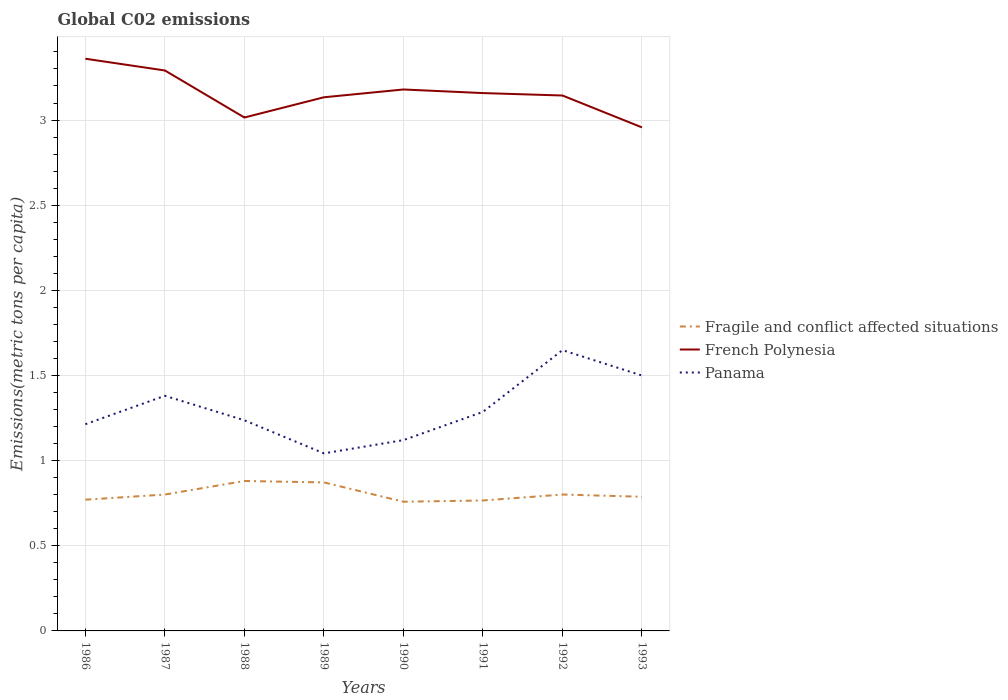How many different coloured lines are there?
Your response must be concise. 3. Across all years, what is the maximum amount of CO2 emitted in in Panama?
Give a very brief answer. 1.04. What is the total amount of CO2 emitted in in Fragile and conflict affected situations in the graph?
Give a very brief answer. 0.01. What is the difference between the highest and the second highest amount of CO2 emitted in in Panama?
Make the answer very short. 0.61. What is the difference between the highest and the lowest amount of CO2 emitted in in French Polynesia?
Ensure brevity in your answer.  4. How many years are there in the graph?
Offer a terse response. 8. Are the values on the major ticks of Y-axis written in scientific E-notation?
Your answer should be compact. No. Does the graph contain any zero values?
Give a very brief answer. No. How many legend labels are there?
Your answer should be very brief. 3. What is the title of the graph?
Provide a succinct answer. Global C02 emissions. Does "Uzbekistan" appear as one of the legend labels in the graph?
Provide a succinct answer. No. What is the label or title of the Y-axis?
Provide a succinct answer. Emissions(metric tons per capita). What is the Emissions(metric tons per capita) of Fragile and conflict affected situations in 1986?
Keep it short and to the point. 0.77. What is the Emissions(metric tons per capita) in French Polynesia in 1986?
Provide a short and direct response. 3.36. What is the Emissions(metric tons per capita) of Panama in 1986?
Offer a terse response. 1.21. What is the Emissions(metric tons per capita) of Fragile and conflict affected situations in 1987?
Make the answer very short. 0.8. What is the Emissions(metric tons per capita) of French Polynesia in 1987?
Provide a succinct answer. 3.29. What is the Emissions(metric tons per capita) of Panama in 1987?
Offer a terse response. 1.38. What is the Emissions(metric tons per capita) in Fragile and conflict affected situations in 1988?
Keep it short and to the point. 0.88. What is the Emissions(metric tons per capita) of French Polynesia in 1988?
Give a very brief answer. 3.01. What is the Emissions(metric tons per capita) of Panama in 1988?
Provide a short and direct response. 1.24. What is the Emissions(metric tons per capita) in Fragile and conflict affected situations in 1989?
Your answer should be compact. 0.87. What is the Emissions(metric tons per capita) in French Polynesia in 1989?
Ensure brevity in your answer.  3.13. What is the Emissions(metric tons per capita) in Panama in 1989?
Give a very brief answer. 1.04. What is the Emissions(metric tons per capita) of Fragile and conflict affected situations in 1990?
Provide a short and direct response. 0.76. What is the Emissions(metric tons per capita) in French Polynesia in 1990?
Provide a short and direct response. 3.18. What is the Emissions(metric tons per capita) in Panama in 1990?
Your answer should be very brief. 1.12. What is the Emissions(metric tons per capita) in Fragile and conflict affected situations in 1991?
Give a very brief answer. 0.77. What is the Emissions(metric tons per capita) in French Polynesia in 1991?
Offer a terse response. 3.16. What is the Emissions(metric tons per capita) in Panama in 1991?
Offer a very short reply. 1.29. What is the Emissions(metric tons per capita) of Fragile and conflict affected situations in 1992?
Your answer should be compact. 0.8. What is the Emissions(metric tons per capita) in French Polynesia in 1992?
Keep it short and to the point. 3.14. What is the Emissions(metric tons per capita) in Panama in 1992?
Provide a short and direct response. 1.65. What is the Emissions(metric tons per capita) of Fragile and conflict affected situations in 1993?
Offer a terse response. 0.79. What is the Emissions(metric tons per capita) in French Polynesia in 1993?
Your answer should be very brief. 2.96. What is the Emissions(metric tons per capita) in Panama in 1993?
Provide a short and direct response. 1.5. Across all years, what is the maximum Emissions(metric tons per capita) in Fragile and conflict affected situations?
Keep it short and to the point. 0.88. Across all years, what is the maximum Emissions(metric tons per capita) in French Polynesia?
Give a very brief answer. 3.36. Across all years, what is the maximum Emissions(metric tons per capita) in Panama?
Offer a terse response. 1.65. Across all years, what is the minimum Emissions(metric tons per capita) of Fragile and conflict affected situations?
Provide a short and direct response. 0.76. Across all years, what is the minimum Emissions(metric tons per capita) in French Polynesia?
Offer a very short reply. 2.96. Across all years, what is the minimum Emissions(metric tons per capita) of Panama?
Make the answer very short. 1.04. What is the total Emissions(metric tons per capita) in Fragile and conflict affected situations in the graph?
Keep it short and to the point. 6.44. What is the total Emissions(metric tons per capita) of French Polynesia in the graph?
Keep it short and to the point. 25.24. What is the total Emissions(metric tons per capita) in Panama in the graph?
Ensure brevity in your answer.  10.43. What is the difference between the Emissions(metric tons per capita) in Fragile and conflict affected situations in 1986 and that in 1987?
Make the answer very short. -0.03. What is the difference between the Emissions(metric tons per capita) of French Polynesia in 1986 and that in 1987?
Provide a succinct answer. 0.07. What is the difference between the Emissions(metric tons per capita) of Panama in 1986 and that in 1987?
Ensure brevity in your answer.  -0.17. What is the difference between the Emissions(metric tons per capita) in Fragile and conflict affected situations in 1986 and that in 1988?
Give a very brief answer. -0.11. What is the difference between the Emissions(metric tons per capita) in French Polynesia in 1986 and that in 1988?
Offer a terse response. 0.35. What is the difference between the Emissions(metric tons per capita) in Panama in 1986 and that in 1988?
Ensure brevity in your answer.  -0.02. What is the difference between the Emissions(metric tons per capita) in Fragile and conflict affected situations in 1986 and that in 1989?
Make the answer very short. -0.1. What is the difference between the Emissions(metric tons per capita) of French Polynesia in 1986 and that in 1989?
Give a very brief answer. 0.23. What is the difference between the Emissions(metric tons per capita) in Panama in 1986 and that in 1989?
Offer a terse response. 0.17. What is the difference between the Emissions(metric tons per capita) in Fragile and conflict affected situations in 1986 and that in 1990?
Your response must be concise. 0.01. What is the difference between the Emissions(metric tons per capita) of French Polynesia in 1986 and that in 1990?
Keep it short and to the point. 0.18. What is the difference between the Emissions(metric tons per capita) in Panama in 1986 and that in 1990?
Offer a terse response. 0.09. What is the difference between the Emissions(metric tons per capita) in Fragile and conflict affected situations in 1986 and that in 1991?
Keep it short and to the point. 0. What is the difference between the Emissions(metric tons per capita) in French Polynesia in 1986 and that in 1991?
Give a very brief answer. 0.2. What is the difference between the Emissions(metric tons per capita) in Panama in 1986 and that in 1991?
Make the answer very short. -0.07. What is the difference between the Emissions(metric tons per capita) of Fragile and conflict affected situations in 1986 and that in 1992?
Your answer should be very brief. -0.03. What is the difference between the Emissions(metric tons per capita) of French Polynesia in 1986 and that in 1992?
Give a very brief answer. 0.22. What is the difference between the Emissions(metric tons per capita) in Panama in 1986 and that in 1992?
Your answer should be compact. -0.43. What is the difference between the Emissions(metric tons per capita) of Fragile and conflict affected situations in 1986 and that in 1993?
Your answer should be compact. -0.02. What is the difference between the Emissions(metric tons per capita) in French Polynesia in 1986 and that in 1993?
Offer a very short reply. 0.4. What is the difference between the Emissions(metric tons per capita) of Panama in 1986 and that in 1993?
Ensure brevity in your answer.  -0.29. What is the difference between the Emissions(metric tons per capita) in Fragile and conflict affected situations in 1987 and that in 1988?
Your answer should be compact. -0.08. What is the difference between the Emissions(metric tons per capita) in French Polynesia in 1987 and that in 1988?
Provide a short and direct response. 0.28. What is the difference between the Emissions(metric tons per capita) in Panama in 1987 and that in 1988?
Keep it short and to the point. 0.14. What is the difference between the Emissions(metric tons per capita) in Fragile and conflict affected situations in 1987 and that in 1989?
Offer a terse response. -0.07. What is the difference between the Emissions(metric tons per capita) of French Polynesia in 1987 and that in 1989?
Provide a short and direct response. 0.16. What is the difference between the Emissions(metric tons per capita) in Panama in 1987 and that in 1989?
Make the answer very short. 0.34. What is the difference between the Emissions(metric tons per capita) of Fragile and conflict affected situations in 1987 and that in 1990?
Your response must be concise. 0.04. What is the difference between the Emissions(metric tons per capita) of French Polynesia in 1987 and that in 1990?
Ensure brevity in your answer.  0.11. What is the difference between the Emissions(metric tons per capita) of Panama in 1987 and that in 1990?
Your answer should be very brief. 0.26. What is the difference between the Emissions(metric tons per capita) of Fragile and conflict affected situations in 1987 and that in 1991?
Your answer should be compact. 0.03. What is the difference between the Emissions(metric tons per capita) in French Polynesia in 1987 and that in 1991?
Keep it short and to the point. 0.13. What is the difference between the Emissions(metric tons per capita) of Panama in 1987 and that in 1991?
Provide a short and direct response. 0.09. What is the difference between the Emissions(metric tons per capita) of French Polynesia in 1987 and that in 1992?
Provide a succinct answer. 0.15. What is the difference between the Emissions(metric tons per capita) of Panama in 1987 and that in 1992?
Your answer should be very brief. -0.27. What is the difference between the Emissions(metric tons per capita) of Fragile and conflict affected situations in 1987 and that in 1993?
Ensure brevity in your answer.  0.01. What is the difference between the Emissions(metric tons per capita) of French Polynesia in 1987 and that in 1993?
Provide a short and direct response. 0.33. What is the difference between the Emissions(metric tons per capita) of Panama in 1987 and that in 1993?
Keep it short and to the point. -0.12. What is the difference between the Emissions(metric tons per capita) in Fragile and conflict affected situations in 1988 and that in 1989?
Keep it short and to the point. 0.01. What is the difference between the Emissions(metric tons per capita) of French Polynesia in 1988 and that in 1989?
Make the answer very short. -0.12. What is the difference between the Emissions(metric tons per capita) of Panama in 1988 and that in 1989?
Keep it short and to the point. 0.19. What is the difference between the Emissions(metric tons per capita) in Fragile and conflict affected situations in 1988 and that in 1990?
Keep it short and to the point. 0.12. What is the difference between the Emissions(metric tons per capita) in French Polynesia in 1988 and that in 1990?
Your answer should be very brief. -0.16. What is the difference between the Emissions(metric tons per capita) in Panama in 1988 and that in 1990?
Provide a short and direct response. 0.12. What is the difference between the Emissions(metric tons per capita) of Fragile and conflict affected situations in 1988 and that in 1991?
Ensure brevity in your answer.  0.11. What is the difference between the Emissions(metric tons per capita) in French Polynesia in 1988 and that in 1991?
Your response must be concise. -0.14. What is the difference between the Emissions(metric tons per capita) in Panama in 1988 and that in 1991?
Provide a short and direct response. -0.05. What is the difference between the Emissions(metric tons per capita) of Fragile and conflict affected situations in 1988 and that in 1992?
Provide a short and direct response. 0.08. What is the difference between the Emissions(metric tons per capita) in French Polynesia in 1988 and that in 1992?
Offer a very short reply. -0.13. What is the difference between the Emissions(metric tons per capita) of Panama in 1988 and that in 1992?
Your answer should be very brief. -0.41. What is the difference between the Emissions(metric tons per capita) of Fragile and conflict affected situations in 1988 and that in 1993?
Your answer should be compact. 0.09. What is the difference between the Emissions(metric tons per capita) in French Polynesia in 1988 and that in 1993?
Offer a very short reply. 0.06. What is the difference between the Emissions(metric tons per capita) of Panama in 1988 and that in 1993?
Offer a terse response. -0.26. What is the difference between the Emissions(metric tons per capita) in Fragile and conflict affected situations in 1989 and that in 1990?
Ensure brevity in your answer.  0.11. What is the difference between the Emissions(metric tons per capita) of French Polynesia in 1989 and that in 1990?
Provide a succinct answer. -0.05. What is the difference between the Emissions(metric tons per capita) in Panama in 1989 and that in 1990?
Keep it short and to the point. -0.08. What is the difference between the Emissions(metric tons per capita) in Fragile and conflict affected situations in 1989 and that in 1991?
Your answer should be very brief. 0.11. What is the difference between the Emissions(metric tons per capita) of French Polynesia in 1989 and that in 1991?
Your answer should be compact. -0.02. What is the difference between the Emissions(metric tons per capita) of Panama in 1989 and that in 1991?
Make the answer very short. -0.24. What is the difference between the Emissions(metric tons per capita) in Fragile and conflict affected situations in 1989 and that in 1992?
Give a very brief answer. 0.07. What is the difference between the Emissions(metric tons per capita) in French Polynesia in 1989 and that in 1992?
Your response must be concise. -0.01. What is the difference between the Emissions(metric tons per capita) in Panama in 1989 and that in 1992?
Offer a terse response. -0.61. What is the difference between the Emissions(metric tons per capita) in Fragile and conflict affected situations in 1989 and that in 1993?
Offer a terse response. 0.08. What is the difference between the Emissions(metric tons per capita) of French Polynesia in 1989 and that in 1993?
Ensure brevity in your answer.  0.18. What is the difference between the Emissions(metric tons per capita) of Panama in 1989 and that in 1993?
Provide a succinct answer. -0.46. What is the difference between the Emissions(metric tons per capita) of Fragile and conflict affected situations in 1990 and that in 1991?
Make the answer very short. -0.01. What is the difference between the Emissions(metric tons per capita) in French Polynesia in 1990 and that in 1991?
Offer a terse response. 0.02. What is the difference between the Emissions(metric tons per capita) of Panama in 1990 and that in 1991?
Offer a very short reply. -0.17. What is the difference between the Emissions(metric tons per capita) in Fragile and conflict affected situations in 1990 and that in 1992?
Provide a short and direct response. -0.04. What is the difference between the Emissions(metric tons per capita) of French Polynesia in 1990 and that in 1992?
Provide a short and direct response. 0.04. What is the difference between the Emissions(metric tons per capita) of Panama in 1990 and that in 1992?
Your answer should be compact. -0.53. What is the difference between the Emissions(metric tons per capita) in Fragile and conflict affected situations in 1990 and that in 1993?
Ensure brevity in your answer.  -0.03. What is the difference between the Emissions(metric tons per capita) of French Polynesia in 1990 and that in 1993?
Keep it short and to the point. 0.22. What is the difference between the Emissions(metric tons per capita) of Panama in 1990 and that in 1993?
Make the answer very short. -0.38. What is the difference between the Emissions(metric tons per capita) in Fragile and conflict affected situations in 1991 and that in 1992?
Offer a very short reply. -0.03. What is the difference between the Emissions(metric tons per capita) of French Polynesia in 1991 and that in 1992?
Give a very brief answer. 0.01. What is the difference between the Emissions(metric tons per capita) of Panama in 1991 and that in 1992?
Provide a short and direct response. -0.36. What is the difference between the Emissions(metric tons per capita) of Fragile and conflict affected situations in 1991 and that in 1993?
Provide a succinct answer. -0.02. What is the difference between the Emissions(metric tons per capita) of French Polynesia in 1991 and that in 1993?
Give a very brief answer. 0.2. What is the difference between the Emissions(metric tons per capita) in Panama in 1991 and that in 1993?
Provide a succinct answer. -0.21. What is the difference between the Emissions(metric tons per capita) of Fragile and conflict affected situations in 1992 and that in 1993?
Provide a short and direct response. 0.01. What is the difference between the Emissions(metric tons per capita) of French Polynesia in 1992 and that in 1993?
Provide a short and direct response. 0.19. What is the difference between the Emissions(metric tons per capita) in Panama in 1992 and that in 1993?
Offer a terse response. 0.15. What is the difference between the Emissions(metric tons per capita) in Fragile and conflict affected situations in 1986 and the Emissions(metric tons per capita) in French Polynesia in 1987?
Provide a short and direct response. -2.52. What is the difference between the Emissions(metric tons per capita) in Fragile and conflict affected situations in 1986 and the Emissions(metric tons per capita) in Panama in 1987?
Your answer should be compact. -0.61. What is the difference between the Emissions(metric tons per capita) of French Polynesia in 1986 and the Emissions(metric tons per capita) of Panama in 1987?
Your answer should be compact. 1.98. What is the difference between the Emissions(metric tons per capita) of Fragile and conflict affected situations in 1986 and the Emissions(metric tons per capita) of French Polynesia in 1988?
Your answer should be compact. -2.24. What is the difference between the Emissions(metric tons per capita) of Fragile and conflict affected situations in 1986 and the Emissions(metric tons per capita) of Panama in 1988?
Provide a succinct answer. -0.47. What is the difference between the Emissions(metric tons per capita) of French Polynesia in 1986 and the Emissions(metric tons per capita) of Panama in 1988?
Give a very brief answer. 2.12. What is the difference between the Emissions(metric tons per capita) of Fragile and conflict affected situations in 1986 and the Emissions(metric tons per capita) of French Polynesia in 1989?
Make the answer very short. -2.36. What is the difference between the Emissions(metric tons per capita) of Fragile and conflict affected situations in 1986 and the Emissions(metric tons per capita) of Panama in 1989?
Your answer should be very brief. -0.27. What is the difference between the Emissions(metric tons per capita) in French Polynesia in 1986 and the Emissions(metric tons per capita) in Panama in 1989?
Provide a succinct answer. 2.32. What is the difference between the Emissions(metric tons per capita) of Fragile and conflict affected situations in 1986 and the Emissions(metric tons per capita) of French Polynesia in 1990?
Give a very brief answer. -2.41. What is the difference between the Emissions(metric tons per capita) of Fragile and conflict affected situations in 1986 and the Emissions(metric tons per capita) of Panama in 1990?
Your answer should be compact. -0.35. What is the difference between the Emissions(metric tons per capita) in French Polynesia in 1986 and the Emissions(metric tons per capita) in Panama in 1990?
Provide a succinct answer. 2.24. What is the difference between the Emissions(metric tons per capita) of Fragile and conflict affected situations in 1986 and the Emissions(metric tons per capita) of French Polynesia in 1991?
Your answer should be compact. -2.39. What is the difference between the Emissions(metric tons per capita) of Fragile and conflict affected situations in 1986 and the Emissions(metric tons per capita) of Panama in 1991?
Your response must be concise. -0.52. What is the difference between the Emissions(metric tons per capita) of French Polynesia in 1986 and the Emissions(metric tons per capita) of Panama in 1991?
Give a very brief answer. 2.07. What is the difference between the Emissions(metric tons per capita) in Fragile and conflict affected situations in 1986 and the Emissions(metric tons per capita) in French Polynesia in 1992?
Give a very brief answer. -2.37. What is the difference between the Emissions(metric tons per capita) of Fragile and conflict affected situations in 1986 and the Emissions(metric tons per capita) of Panama in 1992?
Provide a succinct answer. -0.88. What is the difference between the Emissions(metric tons per capita) in French Polynesia in 1986 and the Emissions(metric tons per capita) in Panama in 1992?
Your answer should be compact. 1.71. What is the difference between the Emissions(metric tons per capita) in Fragile and conflict affected situations in 1986 and the Emissions(metric tons per capita) in French Polynesia in 1993?
Give a very brief answer. -2.19. What is the difference between the Emissions(metric tons per capita) in Fragile and conflict affected situations in 1986 and the Emissions(metric tons per capita) in Panama in 1993?
Your answer should be compact. -0.73. What is the difference between the Emissions(metric tons per capita) of French Polynesia in 1986 and the Emissions(metric tons per capita) of Panama in 1993?
Offer a very short reply. 1.86. What is the difference between the Emissions(metric tons per capita) of Fragile and conflict affected situations in 1987 and the Emissions(metric tons per capita) of French Polynesia in 1988?
Offer a very short reply. -2.21. What is the difference between the Emissions(metric tons per capita) in Fragile and conflict affected situations in 1987 and the Emissions(metric tons per capita) in Panama in 1988?
Make the answer very short. -0.44. What is the difference between the Emissions(metric tons per capita) of French Polynesia in 1987 and the Emissions(metric tons per capita) of Panama in 1988?
Offer a very short reply. 2.05. What is the difference between the Emissions(metric tons per capita) in Fragile and conflict affected situations in 1987 and the Emissions(metric tons per capita) in French Polynesia in 1989?
Give a very brief answer. -2.33. What is the difference between the Emissions(metric tons per capita) of Fragile and conflict affected situations in 1987 and the Emissions(metric tons per capita) of Panama in 1989?
Offer a very short reply. -0.24. What is the difference between the Emissions(metric tons per capita) of French Polynesia in 1987 and the Emissions(metric tons per capita) of Panama in 1989?
Ensure brevity in your answer.  2.25. What is the difference between the Emissions(metric tons per capita) in Fragile and conflict affected situations in 1987 and the Emissions(metric tons per capita) in French Polynesia in 1990?
Make the answer very short. -2.38. What is the difference between the Emissions(metric tons per capita) in Fragile and conflict affected situations in 1987 and the Emissions(metric tons per capita) in Panama in 1990?
Offer a very short reply. -0.32. What is the difference between the Emissions(metric tons per capita) in French Polynesia in 1987 and the Emissions(metric tons per capita) in Panama in 1990?
Provide a succinct answer. 2.17. What is the difference between the Emissions(metric tons per capita) of Fragile and conflict affected situations in 1987 and the Emissions(metric tons per capita) of French Polynesia in 1991?
Give a very brief answer. -2.36. What is the difference between the Emissions(metric tons per capita) in Fragile and conflict affected situations in 1987 and the Emissions(metric tons per capita) in Panama in 1991?
Your answer should be compact. -0.49. What is the difference between the Emissions(metric tons per capita) of French Polynesia in 1987 and the Emissions(metric tons per capita) of Panama in 1991?
Offer a very short reply. 2. What is the difference between the Emissions(metric tons per capita) of Fragile and conflict affected situations in 1987 and the Emissions(metric tons per capita) of French Polynesia in 1992?
Offer a very short reply. -2.34. What is the difference between the Emissions(metric tons per capita) of Fragile and conflict affected situations in 1987 and the Emissions(metric tons per capita) of Panama in 1992?
Your answer should be very brief. -0.85. What is the difference between the Emissions(metric tons per capita) in French Polynesia in 1987 and the Emissions(metric tons per capita) in Panama in 1992?
Give a very brief answer. 1.64. What is the difference between the Emissions(metric tons per capita) of Fragile and conflict affected situations in 1987 and the Emissions(metric tons per capita) of French Polynesia in 1993?
Keep it short and to the point. -2.16. What is the difference between the Emissions(metric tons per capita) in Fragile and conflict affected situations in 1987 and the Emissions(metric tons per capita) in Panama in 1993?
Your answer should be compact. -0.7. What is the difference between the Emissions(metric tons per capita) in French Polynesia in 1987 and the Emissions(metric tons per capita) in Panama in 1993?
Your answer should be compact. 1.79. What is the difference between the Emissions(metric tons per capita) in Fragile and conflict affected situations in 1988 and the Emissions(metric tons per capita) in French Polynesia in 1989?
Provide a succinct answer. -2.25. What is the difference between the Emissions(metric tons per capita) of Fragile and conflict affected situations in 1988 and the Emissions(metric tons per capita) of Panama in 1989?
Keep it short and to the point. -0.16. What is the difference between the Emissions(metric tons per capita) in French Polynesia in 1988 and the Emissions(metric tons per capita) in Panama in 1989?
Offer a terse response. 1.97. What is the difference between the Emissions(metric tons per capita) in Fragile and conflict affected situations in 1988 and the Emissions(metric tons per capita) in French Polynesia in 1990?
Provide a succinct answer. -2.3. What is the difference between the Emissions(metric tons per capita) in Fragile and conflict affected situations in 1988 and the Emissions(metric tons per capita) in Panama in 1990?
Your response must be concise. -0.24. What is the difference between the Emissions(metric tons per capita) in French Polynesia in 1988 and the Emissions(metric tons per capita) in Panama in 1990?
Keep it short and to the point. 1.89. What is the difference between the Emissions(metric tons per capita) in Fragile and conflict affected situations in 1988 and the Emissions(metric tons per capita) in French Polynesia in 1991?
Your response must be concise. -2.28. What is the difference between the Emissions(metric tons per capita) of Fragile and conflict affected situations in 1988 and the Emissions(metric tons per capita) of Panama in 1991?
Your answer should be compact. -0.41. What is the difference between the Emissions(metric tons per capita) in French Polynesia in 1988 and the Emissions(metric tons per capita) in Panama in 1991?
Ensure brevity in your answer.  1.73. What is the difference between the Emissions(metric tons per capita) in Fragile and conflict affected situations in 1988 and the Emissions(metric tons per capita) in French Polynesia in 1992?
Your answer should be very brief. -2.26. What is the difference between the Emissions(metric tons per capita) of Fragile and conflict affected situations in 1988 and the Emissions(metric tons per capita) of Panama in 1992?
Provide a short and direct response. -0.77. What is the difference between the Emissions(metric tons per capita) in French Polynesia in 1988 and the Emissions(metric tons per capita) in Panama in 1992?
Give a very brief answer. 1.37. What is the difference between the Emissions(metric tons per capita) in Fragile and conflict affected situations in 1988 and the Emissions(metric tons per capita) in French Polynesia in 1993?
Your response must be concise. -2.08. What is the difference between the Emissions(metric tons per capita) in Fragile and conflict affected situations in 1988 and the Emissions(metric tons per capita) in Panama in 1993?
Ensure brevity in your answer.  -0.62. What is the difference between the Emissions(metric tons per capita) in French Polynesia in 1988 and the Emissions(metric tons per capita) in Panama in 1993?
Your answer should be compact. 1.52. What is the difference between the Emissions(metric tons per capita) in Fragile and conflict affected situations in 1989 and the Emissions(metric tons per capita) in French Polynesia in 1990?
Keep it short and to the point. -2.31. What is the difference between the Emissions(metric tons per capita) in Fragile and conflict affected situations in 1989 and the Emissions(metric tons per capita) in Panama in 1990?
Ensure brevity in your answer.  -0.25. What is the difference between the Emissions(metric tons per capita) in French Polynesia in 1989 and the Emissions(metric tons per capita) in Panama in 1990?
Provide a succinct answer. 2.01. What is the difference between the Emissions(metric tons per capita) of Fragile and conflict affected situations in 1989 and the Emissions(metric tons per capita) of French Polynesia in 1991?
Provide a short and direct response. -2.29. What is the difference between the Emissions(metric tons per capita) of Fragile and conflict affected situations in 1989 and the Emissions(metric tons per capita) of Panama in 1991?
Offer a very short reply. -0.41. What is the difference between the Emissions(metric tons per capita) in French Polynesia in 1989 and the Emissions(metric tons per capita) in Panama in 1991?
Your response must be concise. 1.85. What is the difference between the Emissions(metric tons per capita) in Fragile and conflict affected situations in 1989 and the Emissions(metric tons per capita) in French Polynesia in 1992?
Ensure brevity in your answer.  -2.27. What is the difference between the Emissions(metric tons per capita) of Fragile and conflict affected situations in 1989 and the Emissions(metric tons per capita) of Panama in 1992?
Offer a terse response. -0.78. What is the difference between the Emissions(metric tons per capita) of French Polynesia in 1989 and the Emissions(metric tons per capita) of Panama in 1992?
Your response must be concise. 1.48. What is the difference between the Emissions(metric tons per capita) in Fragile and conflict affected situations in 1989 and the Emissions(metric tons per capita) in French Polynesia in 1993?
Offer a terse response. -2.08. What is the difference between the Emissions(metric tons per capita) of Fragile and conflict affected situations in 1989 and the Emissions(metric tons per capita) of Panama in 1993?
Offer a terse response. -0.63. What is the difference between the Emissions(metric tons per capita) of French Polynesia in 1989 and the Emissions(metric tons per capita) of Panama in 1993?
Provide a succinct answer. 1.63. What is the difference between the Emissions(metric tons per capita) of Fragile and conflict affected situations in 1990 and the Emissions(metric tons per capita) of French Polynesia in 1991?
Provide a short and direct response. -2.4. What is the difference between the Emissions(metric tons per capita) of Fragile and conflict affected situations in 1990 and the Emissions(metric tons per capita) of Panama in 1991?
Provide a succinct answer. -0.53. What is the difference between the Emissions(metric tons per capita) in French Polynesia in 1990 and the Emissions(metric tons per capita) in Panama in 1991?
Offer a very short reply. 1.89. What is the difference between the Emissions(metric tons per capita) in Fragile and conflict affected situations in 1990 and the Emissions(metric tons per capita) in French Polynesia in 1992?
Provide a short and direct response. -2.39. What is the difference between the Emissions(metric tons per capita) in Fragile and conflict affected situations in 1990 and the Emissions(metric tons per capita) in Panama in 1992?
Offer a terse response. -0.89. What is the difference between the Emissions(metric tons per capita) in French Polynesia in 1990 and the Emissions(metric tons per capita) in Panama in 1992?
Make the answer very short. 1.53. What is the difference between the Emissions(metric tons per capita) of Fragile and conflict affected situations in 1990 and the Emissions(metric tons per capita) of French Polynesia in 1993?
Your answer should be very brief. -2.2. What is the difference between the Emissions(metric tons per capita) of Fragile and conflict affected situations in 1990 and the Emissions(metric tons per capita) of Panama in 1993?
Your response must be concise. -0.74. What is the difference between the Emissions(metric tons per capita) in French Polynesia in 1990 and the Emissions(metric tons per capita) in Panama in 1993?
Provide a short and direct response. 1.68. What is the difference between the Emissions(metric tons per capita) in Fragile and conflict affected situations in 1991 and the Emissions(metric tons per capita) in French Polynesia in 1992?
Provide a short and direct response. -2.38. What is the difference between the Emissions(metric tons per capita) in Fragile and conflict affected situations in 1991 and the Emissions(metric tons per capita) in Panama in 1992?
Provide a short and direct response. -0.88. What is the difference between the Emissions(metric tons per capita) in French Polynesia in 1991 and the Emissions(metric tons per capita) in Panama in 1992?
Your response must be concise. 1.51. What is the difference between the Emissions(metric tons per capita) in Fragile and conflict affected situations in 1991 and the Emissions(metric tons per capita) in French Polynesia in 1993?
Provide a short and direct response. -2.19. What is the difference between the Emissions(metric tons per capita) of Fragile and conflict affected situations in 1991 and the Emissions(metric tons per capita) of Panama in 1993?
Your answer should be compact. -0.73. What is the difference between the Emissions(metric tons per capita) in French Polynesia in 1991 and the Emissions(metric tons per capita) in Panama in 1993?
Make the answer very short. 1.66. What is the difference between the Emissions(metric tons per capita) in Fragile and conflict affected situations in 1992 and the Emissions(metric tons per capita) in French Polynesia in 1993?
Offer a terse response. -2.16. What is the difference between the Emissions(metric tons per capita) of Fragile and conflict affected situations in 1992 and the Emissions(metric tons per capita) of Panama in 1993?
Make the answer very short. -0.7. What is the difference between the Emissions(metric tons per capita) in French Polynesia in 1992 and the Emissions(metric tons per capita) in Panama in 1993?
Keep it short and to the point. 1.64. What is the average Emissions(metric tons per capita) of Fragile and conflict affected situations per year?
Make the answer very short. 0.8. What is the average Emissions(metric tons per capita) of French Polynesia per year?
Make the answer very short. 3.15. What is the average Emissions(metric tons per capita) of Panama per year?
Make the answer very short. 1.3. In the year 1986, what is the difference between the Emissions(metric tons per capita) of Fragile and conflict affected situations and Emissions(metric tons per capita) of French Polynesia?
Make the answer very short. -2.59. In the year 1986, what is the difference between the Emissions(metric tons per capita) in Fragile and conflict affected situations and Emissions(metric tons per capita) in Panama?
Your response must be concise. -0.44. In the year 1986, what is the difference between the Emissions(metric tons per capita) in French Polynesia and Emissions(metric tons per capita) in Panama?
Your answer should be compact. 2.15. In the year 1987, what is the difference between the Emissions(metric tons per capita) in Fragile and conflict affected situations and Emissions(metric tons per capita) in French Polynesia?
Provide a short and direct response. -2.49. In the year 1987, what is the difference between the Emissions(metric tons per capita) of Fragile and conflict affected situations and Emissions(metric tons per capita) of Panama?
Provide a succinct answer. -0.58. In the year 1987, what is the difference between the Emissions(metric tons per capita) of French Polynesia and Emissions(metric tons per capita) of Panama?
Keep it short and to the point. 1.91. In the year 1988, what is the difference between the Emissions(metric tons per capita) in Fragile and conflict affected situations and Emissions(metric tons per capita) in French Polynesia?
Make the answer very short. -2.13. In the year 1988, what is the difference between the Emissions(metric tons per capita) in Fragile and conflict affected situations and Emissions(metric tons per capita) in Panama?
Provide a succinct answer. -0.36. In the year 1988, what is the difference between the Emissions(metric tons per capita) of French Polynesia and Emissions(metric tons per capita) of Panama?
Ensure brevity in your answer.  1.78. In the year 1989, what is the difference between the Emissions(metric tons per capita) in Fragile and conflict affected situations and Emissions(metric tons per capita) in French Polynesia?
Your response must be concise. -2.26. In the year 1989, what is the difference between the Emissions(metric tons per capita) of Fragile and conflict affected situations and Emissions(metric tons per capita) of Panama?
Keep it short and to the point. -0.17. In the year 1989, what is the difference between the Emissions(metric tons per capita) of French Polynesia and Emissions(metric tons per capita) of Panama?
Provide a short and direct response. 2.09. In the year 1990, what is the difference between the Emissions(metric tons per capita) in Fragile and conflict affected situations and Emissions(metric tons per capita) in French Polynesia?
Offer a terse response. -2.42. In the year 1990, what is the difference between the Emissions(metric tons per capita) of Fragile and conflict affected situations and Emissions(metric tons per capita) of Panama?
Make the answer very short. -0.36. In the year 1990, what is the difference between the Emissions(metric tons per capita) in French Polynesia and Emissions(metric tons per capita) in Panama?
Provide a short and direct response. 2.06. In the year 1991, what is the difference between the Emissions(metric tons per capita) of Fragile and conflict affected situations and Emissions(metric tons per capita) of French Polynesia?
Provide a succinct answer. -2.39. In the year 1991, what is the difference between the Emissions(metric tons per capita) in Fragile and conflict affected situations and Emissions(metric tons per capita) in Panama?
Offer a very short reply. -0.52. In the year 1991, what is the difference between the Emissions(metric tons per capita) of French Polynesia and Emissions(metric tons per capita) of Panama?
Provide a succinct answer. 1.87. In the year 1992, what is the difference between the Emissions(metric tons per capita) of Fragile and conflict affected situations and Emissions(metric tons per capita) of French Polynesia?
Your answer should be very brief. -2.34. In the year 1992, what is the difference between the Emissions(metric tons per capita) of Fragile and conflict affected situations and Emissions(metric tons per capita) of Panama?
Offer a very short reply. -0.85. In the year 1992, what is the difference between the Emissions(metric tons per capita) of French Polynesia and Emissions(metric tons per capita) of Panama?
Make the answer very short. 1.5. In the year 1993, what is the difference between the Emissions(metric tons per capita) of Fragile and conflict affected situations and Emissions(metric tons per capita) of French Polynesia?
Your response must be concise. -2.17. In the year 1993, what is the difference between the Emissions(metric tons per capita) in Fragile and conflict affected situations and Emissions(metric tons per capita) in Panama?
Your response must be concise. -0.71. In the year 1993, what is the difference between the Emissions(metric tons per capita) of French Polynesia and Emissions(metric tons per capita) of Panama?
Your response must be concise. 1.46. What is the ratio of the Emissions(metric tons per capita) in Fragile and conflict affected situations in 1986 to that in 1987?
Your answer should be compact. 0.96. What is the ratio of the Emissions(metric tons per capita) in French Polynesia in 1986 to that in 1987?
Offer a terse response. 1.02. What is the ratio of the Emissions(metric tons per capita) of Panama in 1986 to that in 1987?
Offer a terse response. 0.88. What is the ratio of the Emissions(metric tons per capita) of Fragile and conflict affected situations in 1986 to that in 1988?
Make the answer very short. 0.88. What is the ratio of the Emissions(metric tons per capita) of French Polynesia in 1986 to that in 1988?
Your answer should be compact. 1.11. What is the ratio of the Emissions(metric tons per capita) of Panama in 1986 to that in 1988?
Offer a very short reply. 0.98. What is the ratio of the Emissions(metric tons per capita) of Fragile and conflict affected situations in 1986 to that in 1989?
Ensure brevity in your answer.  0.88. What is the ratio of the Emissions(metric tons per capita) of French Polynesia in 1986 to that in 1989?
Your response must be concise. 1.07. What is the ratio of the Emissions(metric tons per capita) of Panama in 1986 to that in 1989?
Keep it short and to the point. 1.16. What is the ratio of the Emissions(metric tons per capita) in Fragile and conflict affected situations in 1986 to that in 1990?
Offer a very short reply. 1.02. What is the ratio of the Emissions(metric tons per capita) of French Polynesia in 1986 to that in 1990?
Your response must be concise. 1.06. What is the ratio of the Emissions(metric tons per capita) of Panama in 1986 to that in 1990?
Provide a succinct answer. 1.08. What is the ratio of the Emissions(metric tons per capita) of Fragile and conflict affected situations in 1986 to that in 1991?
Your response must be concise. 1.01. What is the ratio of the Emissions(metric tons per capita) of French Polynesia in 1986 to that in 1991?
Your response must be concise. 1.06. What is the ratio of the Emissions(metric tons per capita) of Panama in 1986 to that in 1991?
Your response must be concise. 0.94. What is the ratio of the Emissions(metric tons per capita) of Fragile and conflict affected situations in 1986 to that in 1992?
Give a very brief answer. 0.96. What is the ratio of the Emissions(metric tons per capita) of French Polynesia in 1986 to that in 1992?
Keep it short and to the point. 1.07. What is the ratio of the Emissions(metric tons per capita) in Panama in 1986 to that in 1992?
Your response must be concise. 0.74. What is the ratio of the Emissions(metric tons per capita) in Fragile and conflict affected situations in 1986 to that in 1993?
Provide a short and direct response. 0.98. What is the ratio of the Emissions(metric tons per capita) in French Polynesia in 1986 to that in 1993?
Offer a terse response. 1.14. What is the ratio of the Emissions(metric tons per capita) of Panama in 1986 to that in 1993?
Offer a very short reply. 0.81. What is the ratio of the Emissions(metric tons per capita) in Fragile and conflict affected situations in 1987 to that in 1988?
Keep it short and to the point. 0.91. What is the ratio of the Emissions(metric tons per capita) of French Polynesia in 1987 to that in 1988?
Give a very brief answer. 1.09. What is the ratio of the Emissions(metric tons per capita) in Panama in 1987 to that in 1988?
Your response must be concise. 1.12. What is the ratio of the Emissions(metric tons per capita) in Fragile and conflict affected situations in 1987 to that in 1989?
Offer a very short reply. 0.92. What is the ratio of the Emissions(metric tons per capita) in French Polynesia in 1987 to that in 1989?
Your response must be concise. 1.05. What is the ratio of the Emissions(metric tons per capita) in Panama in 1987 to that in 1989?
Offer a terse response. 1.32. What is the ratio of the Emissions(metric tons per capita) in Fragile and conflict affected situations in 1987 to that in 1990?
Provide a short and direct response. 1.06. What is the ratio of the Emissions(metric tons per capita) in French Polynesia in 1987 to that in 1990?
Make the answer very short. 1.04. What is the ratio of the Emissions(metric tons per capita) in Panama in 1987 to that in 1990?
Your response must be concise. 1.23. What is the ratio of the Emissions(metric tons per capita) of Fragile and conflict affected situations in 1987 to that in 1991?
Your answer should be compact. 1.05. What is the ratio of the Emissions(metric tons per capita) of French Polynesia in 1987 to that in 1991?
Keep it short and to the point. 1.04. What is the ratio of the Emissions(metric tons per capita) of Panama in 1987 to that in 1991?
Ensure brevity in your answer.  1.07. What is the ratio of the Emissions(metric tons per capita) of French Polynesia in 1987 to that in 1992?
Your answer should be very brief. 1.05. What is the ratio of the Emissions(metric tons per capita) of Panama in 1987 to that in 1992?
Provide a succinct answer. 0.84. What is the ratio of the Emissions(metric tons per capita) of Fragile and conflict affected situations in 1987 to that in 1993?
Your answer should be compact. 1.02. What is the ratio of the Emissions(metric tons per capita) in French Polynesia in 1987 to that in 1993?
Ensure brevity in your answer.  1.11. What is the ratio of the Emissions(metric tons per capita) of Panama in 1987 to that in 1993?
Your answer should be compact. 0.92. What is the ratio of the Emissions(metric tons per capita) in Fragile and conflict affected situations in 1988 to that in 1989?
Provide a short and direct response. 1.01. What is the ratio of the Emissions(metric tons per capita) in French Polynesia in 1988 to that in 1989?
Make the answer very short. 0.96. What is the ratio of the Emissions(metric tons per capita) of Panama in 1988 to that in 1989?
Ensure brevity in your answer.  1.19. What is the ratio of the Emissions(metric tons per capita) in Fragile and conflict affected situations in 1988 to that in 1990?
Your answer should be compact. 1.16. What is the ratio of the Emissions(metric tons per capita) in French Polynesia in 1988 to that in 1990?
Your answer should be compact. 0.95. What is the ratio of the Emissions(metric tons per capita) in Panama in 1988 to that in 1990?
Provide a short and direct response. 1.1. What is the ratio of the Emissions(metric tons per capita) in Fragile and conflict affected situations in 1988 to that in 1991?
Your answer should be very brief. 1.15. What is the ratio of the Emissions(metric tons per capita) in French Polynesia in 1988 to that in 1991?
Provide a short and direct response. 0.95. What is the ratio of the Emissions(metric tons per capita) in Panama in 1988 to that in 1991?
Your answer should be very brief. 0.96. What is the ratio of the Emissions(metric tons per capita) of Fragile and conflict affected situations in 1988 to that in 1992?
Give a very brief answer. 1.1. What is the ratio of the Emissions(metric tons per capita) of French Polynesia in 1988 to that in 1992?
Ensure brevity in your answer.  0.96. What is the ratio of the Emissions(metric tons per capita) in Panama in 1988 to that in 1992?
Provide a succinct answer. 0.75. What is the ratio of the Emissions(metric tons per capita) in Fragile and conflict affected situations in 1988 to that in 1993?
Your answer should be compact. 1.12. What is the ratio of the Emissions(metric tons per capita) of French Polynesia in 1988 to that in 1993?
Make the answer very short. 1.02. What is the ratio of the Emissions(metric tons per capita) in Panama in 1988 to that in 1993?
Your response must be concise. 0.82. What is the ratio of the Emissions(metric tons per capita) in Fragile and conflict affected situations in 1989 to that in 1990?
Your answer should be very brief. 1.15. What is the ratio of the Emissions(metric tons per capita) in French Polynesia in 1989 to that in 1990?
Provide a succinct answer. 0.99. What is the ratio of the Emissions(metric tons per capita) in Panama in 1989 to that in 1990?
Offer a very short reply. 0.93. What is the ratio of the Emissions(metric tons per capita) in Fragile and conflict affected situations in 1989 to that in 1991?
Offer a very short reply. 1.14. What is the ratio of the Emissions(metric tons per capita) in Panama in 1989 to that in 1991?
Your answer should be very brief. 0.81. What is the ratio of the Emissions(metric tons per capita) of Fragile and conflict affected situations in 1989 to that in 1992?
Keep it short and to the point. 1.09. What is the ratio of the Emissions(metric tons per capita) in French Polynesia in 1989 to that in 1992?
Your answer should be very brief. 1. What is the ratio of the Emissions(metric tons per capita) of Panama in 1989 to that in 1992?
Provide a short and direct response. 0.63. What is the ratio of the Emissions(metric tons per capita) in Fragile and conflict affected situations in 1989 to that in 1993?
Give a very brief answer. 1.11. What is the ratio of the Emissions(metric tons per capita) in French Polynesia in 1989 to that in 1993?
Offer a very short reply. 1.06. What is the ratio of the Emissions(metric tons per capita) of Panama in 1989 to that in 1993?
Ensure brevity in your answer.  0.7. What is the ratio of the Emissions(metric tons per capita) of French Polynesia in 1990 to that in 1991?
Offer a very short reply. 1.01. What is the ratio of the Emissions(metric tons per capita) of Panama in 1990 to that in 1991?
Your answer should be compact. 0.87. What is the ratio of the Emissions(metric tons per capita) of Fragile and conflict affected situations in 1990 to that in 1992?
Your answer should be very brief. 0.95. What is the ratio of the Emissions(metric tons per capita) of French Polynesia in 1990 to that in 1992?
Your answer should be very brief. 1.01. What is the ratio of the Emissions(metric tons per capita) of Panama in 1990 to that in 1992?
Ensure brevity in your answer.  0.68. What is the ratio of the Emissions(metric tons per capita) of French Polynesia in 1990 to that in 1993?
Keep it short and to the point. 1.08. What is the ratio of the Emissions(metric tons per capita) of Panama in 1990 to that in 1993?
Your response must be concise. 0.75. What is the ratio of the Emissions(metric tons per capita) of Fragile and conflict affected situations in 1991 to that in 1992?
Your answer should be compact. 0.96. What is the ratio of the Emissions(metric tons per capita) in Panama in 1991 to that in 1992?
Offer a terse response. 0.78. What is the ratio of the Emissions(metric tons per capita) in Fragile and conflict affected situations in 1991 to that in 1993?
Offer a very short reply. 0.97. What is the ratio of the Emissions(metric tons per capita) of French Polynesia in 1991 to that in 1993?
Offer a very short reply. 1.07. What is the ratio of the Emissions(metric tons per capita) of Panama in 1991 to that in 1993?
Your answer should be very brief. 0.86. What is the ratio of the Emissions(metric tons per capita) in Fragile and conflict affected situations in 1992 to that in 1993?
Give a very brief answer. 1.02. What is the ratio of the Emissions(metric tons per capita) of French Polynesia in 1992 to that in 1993?
Provide a succinct answer. 1.06. What is the ratio of the Emissions(metric tons per capita) of Panama in 1992 to that in 1993?
Offer a terse response. 1.1. What is the difference between the highest and the second highest Emissions(metric tons per capita) of Fragile and conflict affected situations?
Offer a very short reply. 0.01. What is the difference between the highest and the second highest Emissions(metric tons per capita) of French Polynesia?
Offer a very short reply. 0.07. What is the difference between the highest and the second highest Emissions(metric tons per capita) in Panama?
Your answer should be compact. 0.15. What is the difference between the highest and the lowest Emissions(metric tons per capita) of Fragile and conflict affected situations?
Your response must be concise. 0.12. What is the difference between the highest and the lowest Emissions(metric tons per capita) in French Polynesia?
Make the answer very short. 0.4. What is the difference between the highest and the lowest Emissions(metric tons per capita) in Panama?
Offer a terse response. 0.61. 